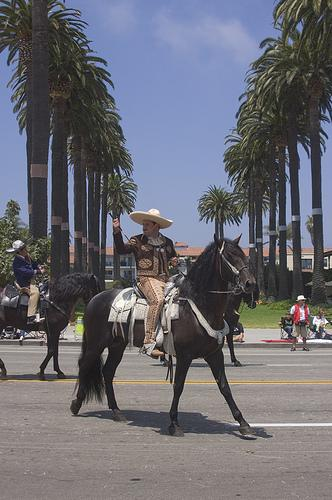What type of hat is the man wearing? sombrero 